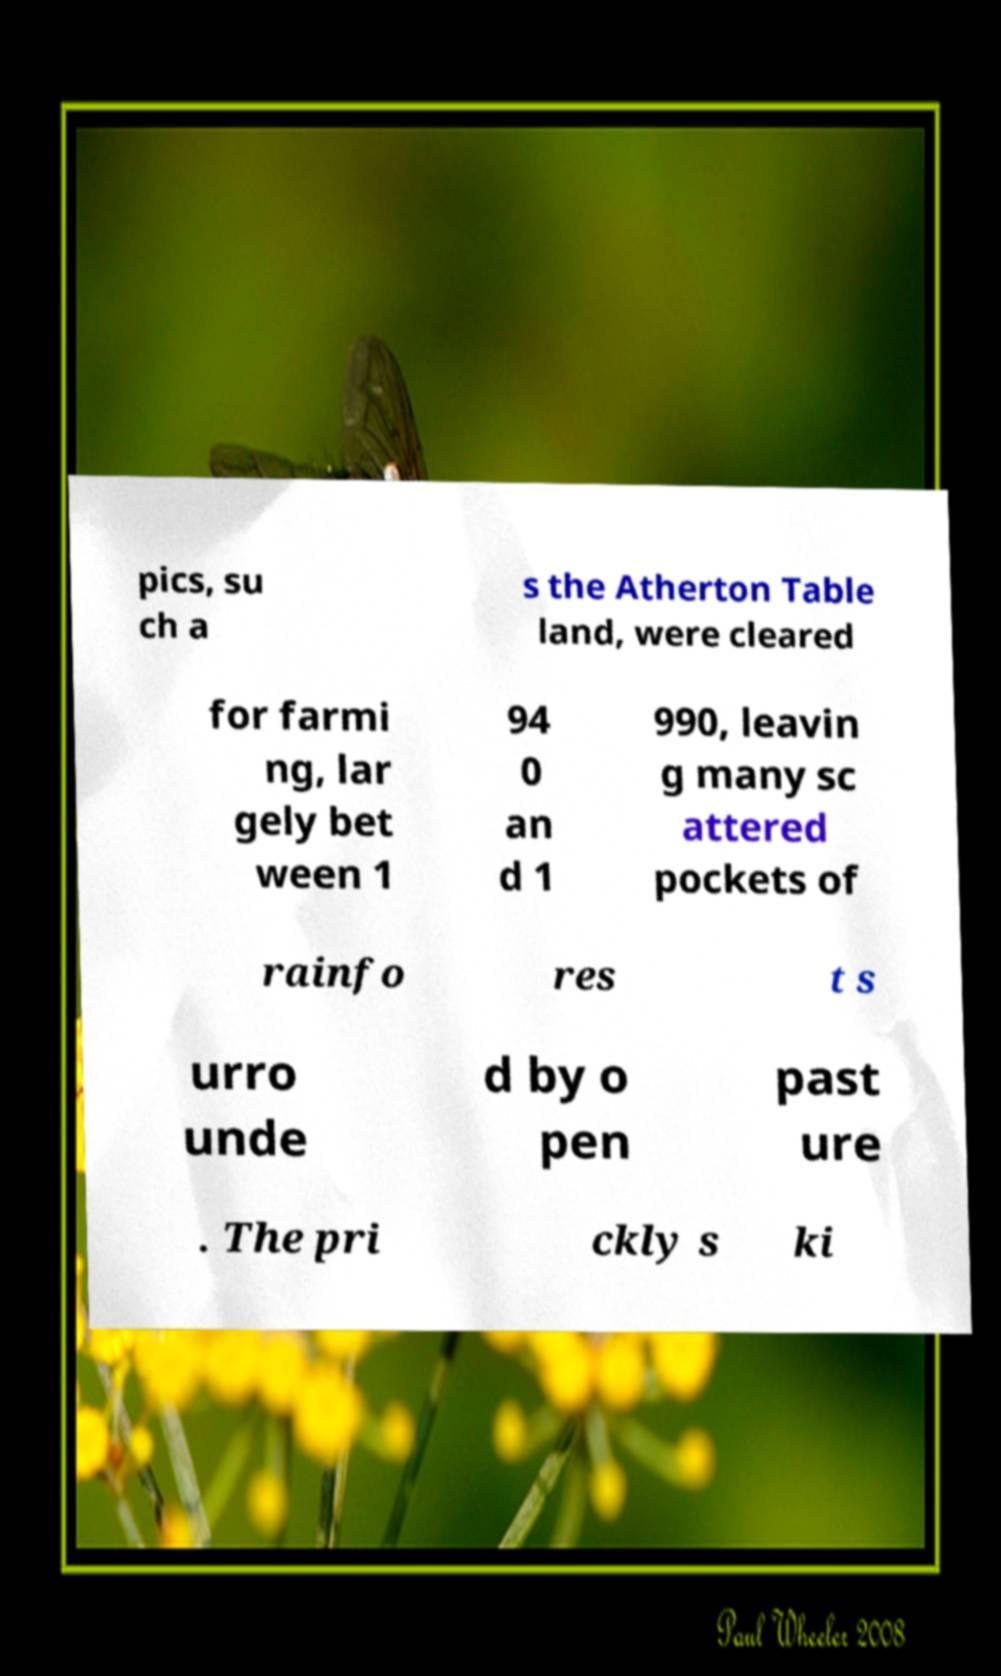What messages or text are displayed in this image? I need them in a readable, typed format. pics, su ch a s the Atherton Table land, were cleared for farmi ng, lar gely bet ween 1 94 0 an d 1 990, leavin g many sc attered pockets of rainfo res t s urro unde d by o pen past ure . The pri ckly s ki 